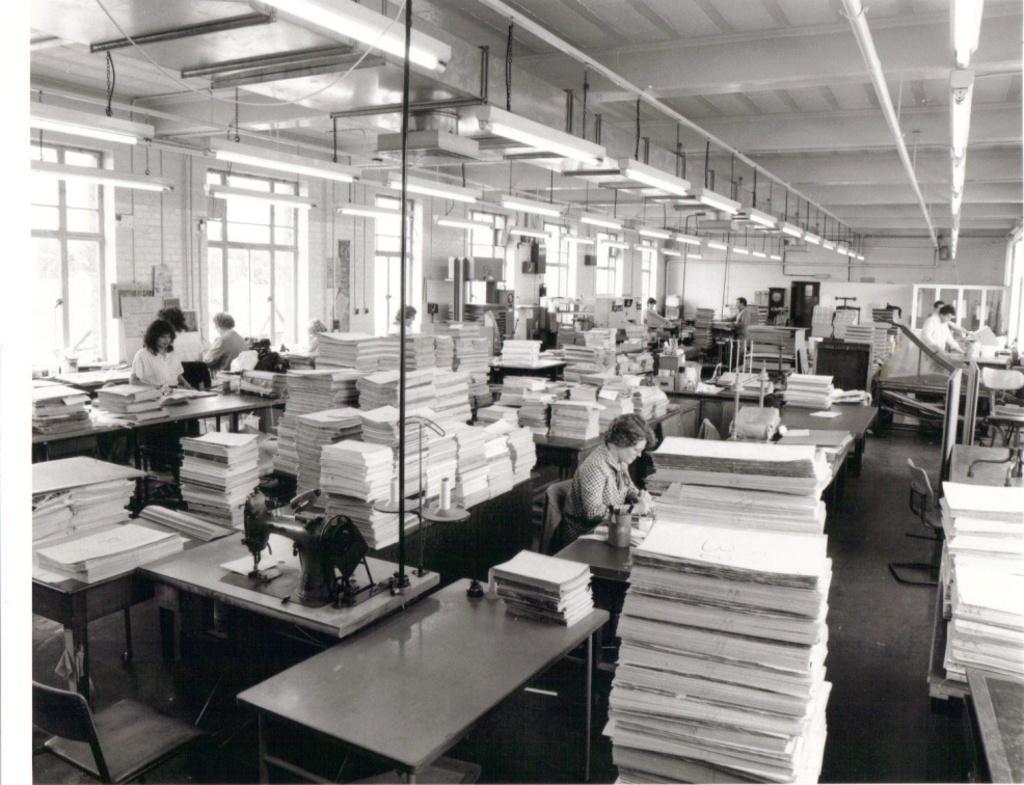Describe this image in one or two sentences. In this picture we can see some persons sitting on the chairs. These are the tables. And this is a machine. And there are some books on the table. This is the floor. And these are the lights and this is the roof. 